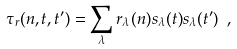Convert formula to latex. <formula><loc_0><loc_0><loc_500><loc_500>\tau _ { r } ( n , { t } , { t ^ { \prime } } ) = \sum _ { \lambda } r _ { \lambda } ( n ) s _ { \lambda } ( { t } ) s _ { \lambda } ( { t ^ { \prime } } ) \ ,</formula> 